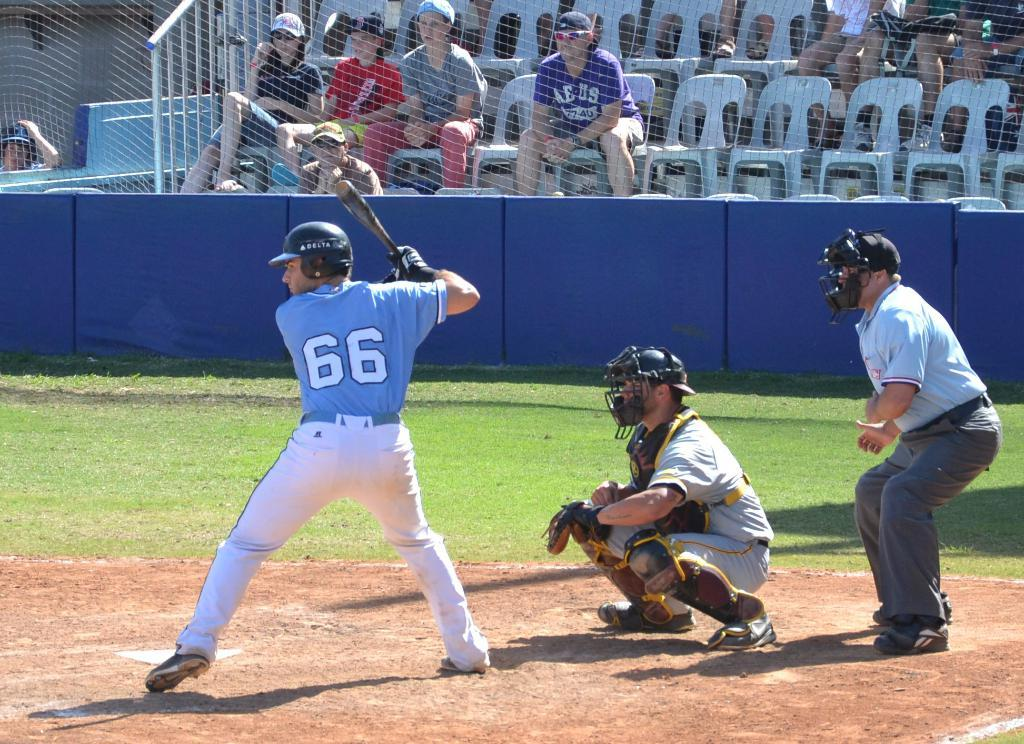<image>
Offer a succinct explanation of the picture presented. a batter that is wearing the number 66 on their jersey 